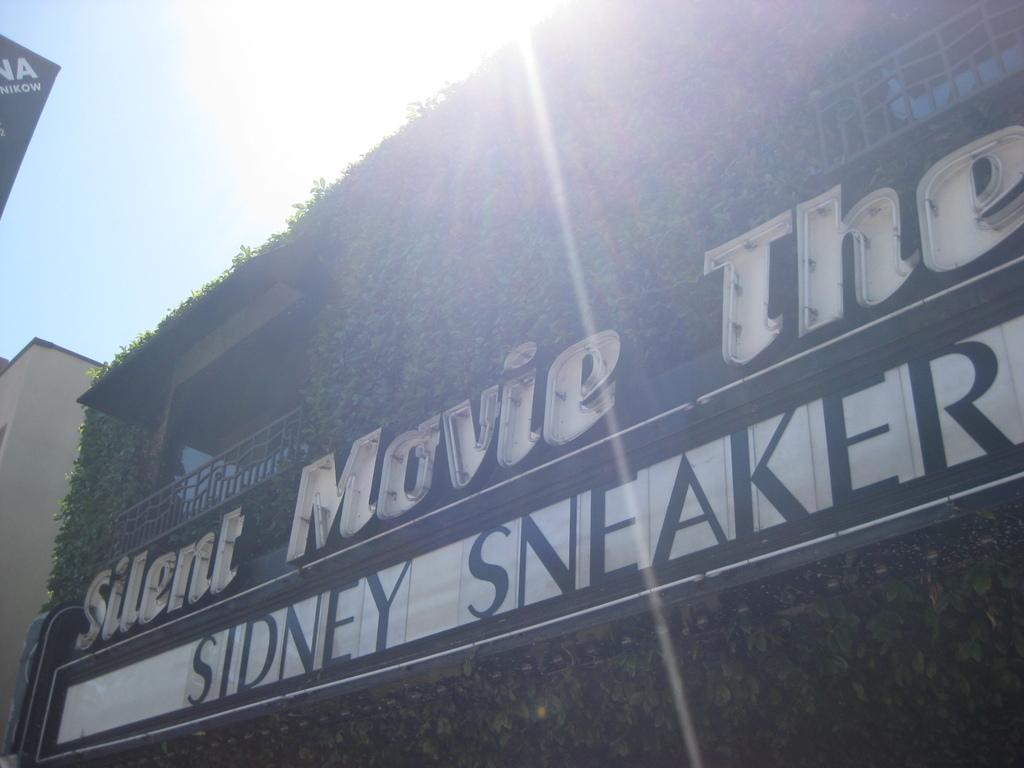<image>
Provide a brief description of the given image. A silent movie theater displaying an ad for Sidney Sneaker. 